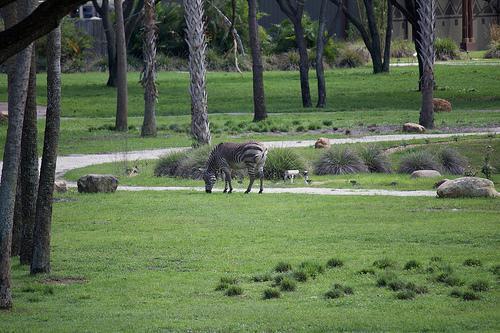How many zebras are there?
Give a very brief answer. 1. 